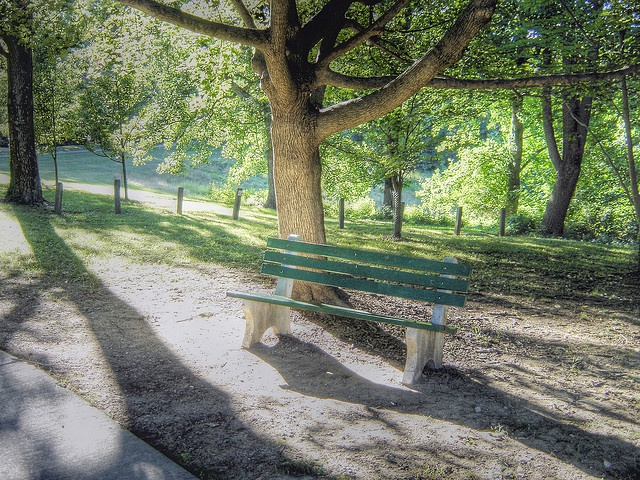Describe the objects in this image and their specific colors. I can see a bench in black, teal, gray, and darkgray tones in this image. 